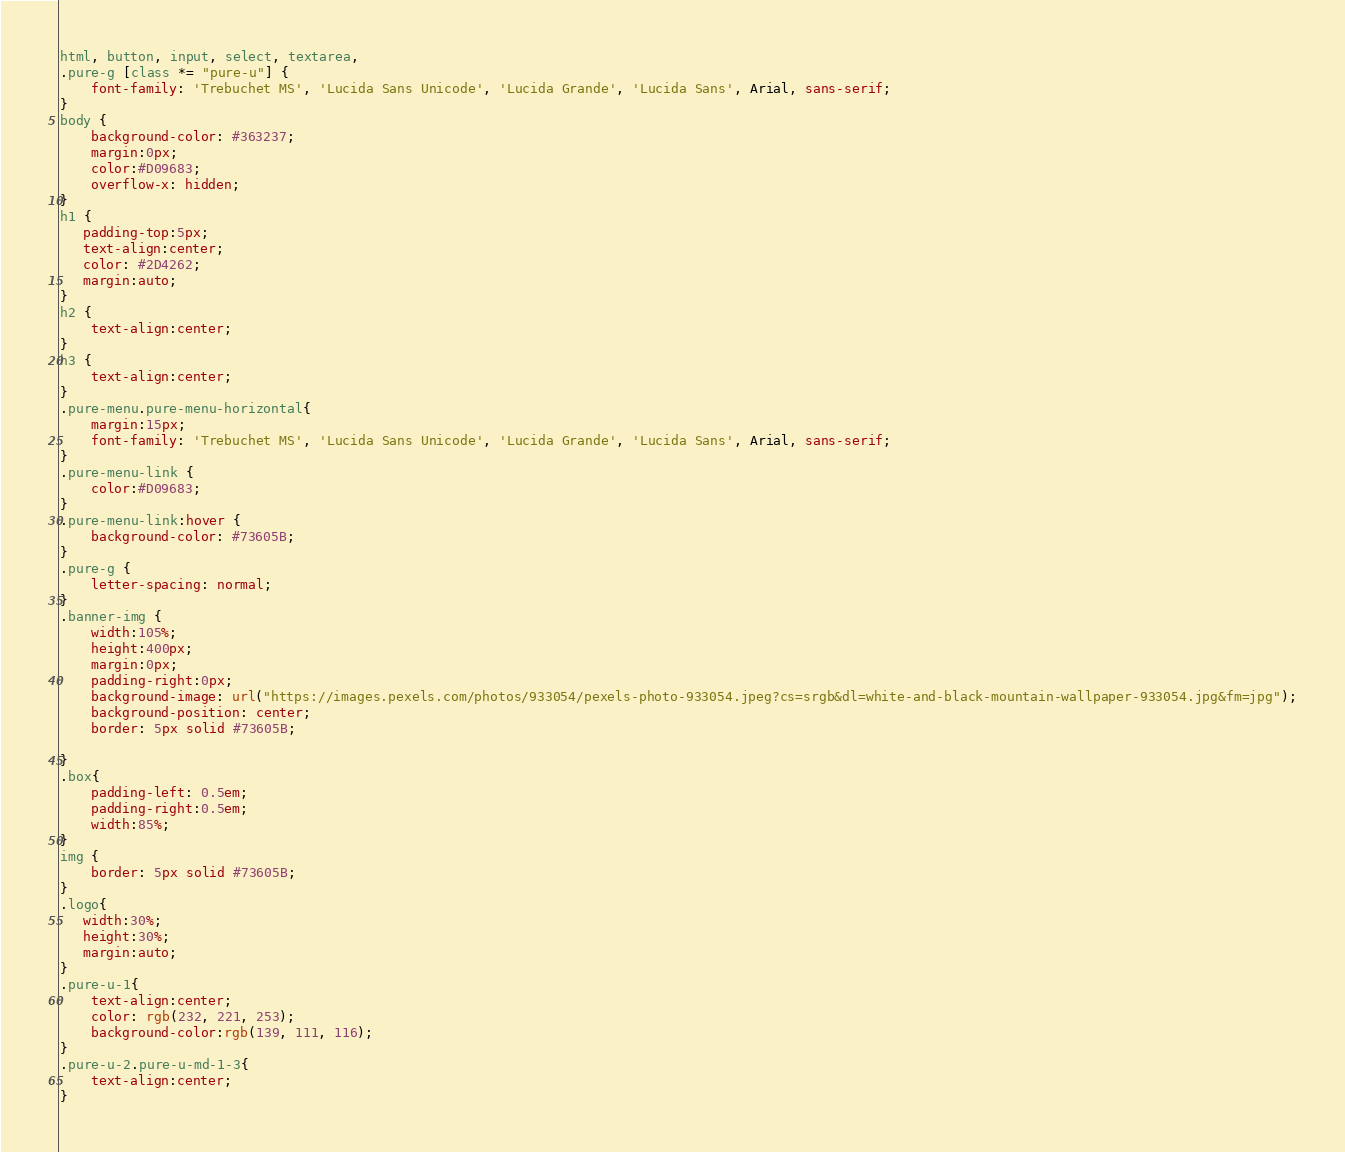Convert code to text. <code><loc_0><loc_0><loc_500><loc_500><_CSS_>html, button, input, select, textarea,
.pure-g [class *= "pure-u"] {
    font-family: 'Trebuchet MS', 'Lucida Sans Unicode', 'Lucida Grande', 'Lucida Sans', Arial, sans-serif;
}
body {
    background-color: #363237;
    margin:0px;
    color:#D09683;
    overflow-x: hidden;
}
h1 {
   padding-top:5px;
   text-align:center;
   color: #2D4262;
   margin:auto;
}
h2 {
    text-align:center;  
}
h3 {
    text-align:center;  
}
.pure-menu.pure-menu-horizontal{
    margin:15px;
    font-family: 'Trebuchet MS', 'Lucida Sans Unicode', 'Lucida Grande', 'Lucida Sans', Arial, sans-serif;
}
.pure-menu-link {
    color:#D09683;
}
.pure-menu-link:hover {
    background-color: #73605B; 
}
.pure-g {
    letter-spacing: normal;
}
.banner-img {
    width:105%;
    height:400px;
    margin:0px;
    padding-right:0px;
    background-image: url("https://images.pexels.com/photos/933054/pexels-photo-933054.jpeg?cs=srgb&dl=white-and-black-mountain-wallpaper-933054.jpg&fm=jpg");
    background-position: center;
    border: 5px solid #73605B;

}
.box{
    padding-left: 0.5em;
    padding-right:0.5em;
    width:85%;
}
img {
    border: 5px solid #73605B;
}
.logo{
   width:30%;
   height:30%;
   margin:auto; 
}
.pure-u-1{
    text-align:center;
    color: rgb(232, 221, 253);
    background-color:rgb(139, 111, 116);
}
.pure-u-2.pure-u-md-1-3{
    text-align:center;
}



</code> 